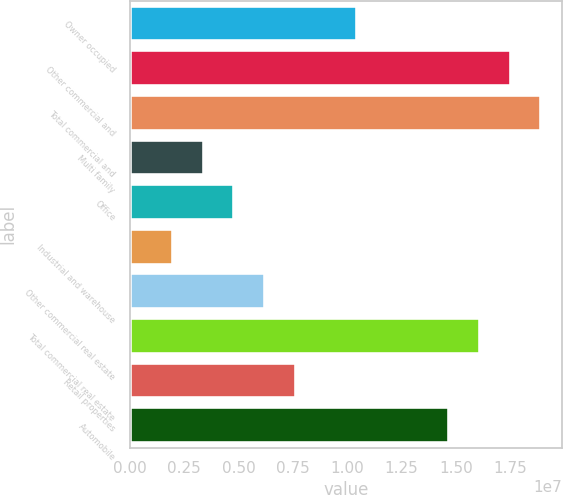<chart> <loc_0><loc_0><loc_500><loc_500><bar_chart><fcel>Owner occupied<fcel>Other commercial and<fcel>Total commercial and<fcel>Multi family<fcel>Office<fcel>Industrial and warehouse<fcel>Other commercial real estate<fcel>Total commercial real estate<fcel>Retail properties<fcel>Automobile<nl><fcel>1.04587e+07<fcel>1.75265e+07<fcel>1.894e+07<fcel>3.39094e+06<fcel>4.80449e+06<fcel>1.97738e+06<fcel>6.21804e+06<fcel>1.61129e+07<fcel>7.6316e+06<fcel>1.46994e+07<nl></chart> 